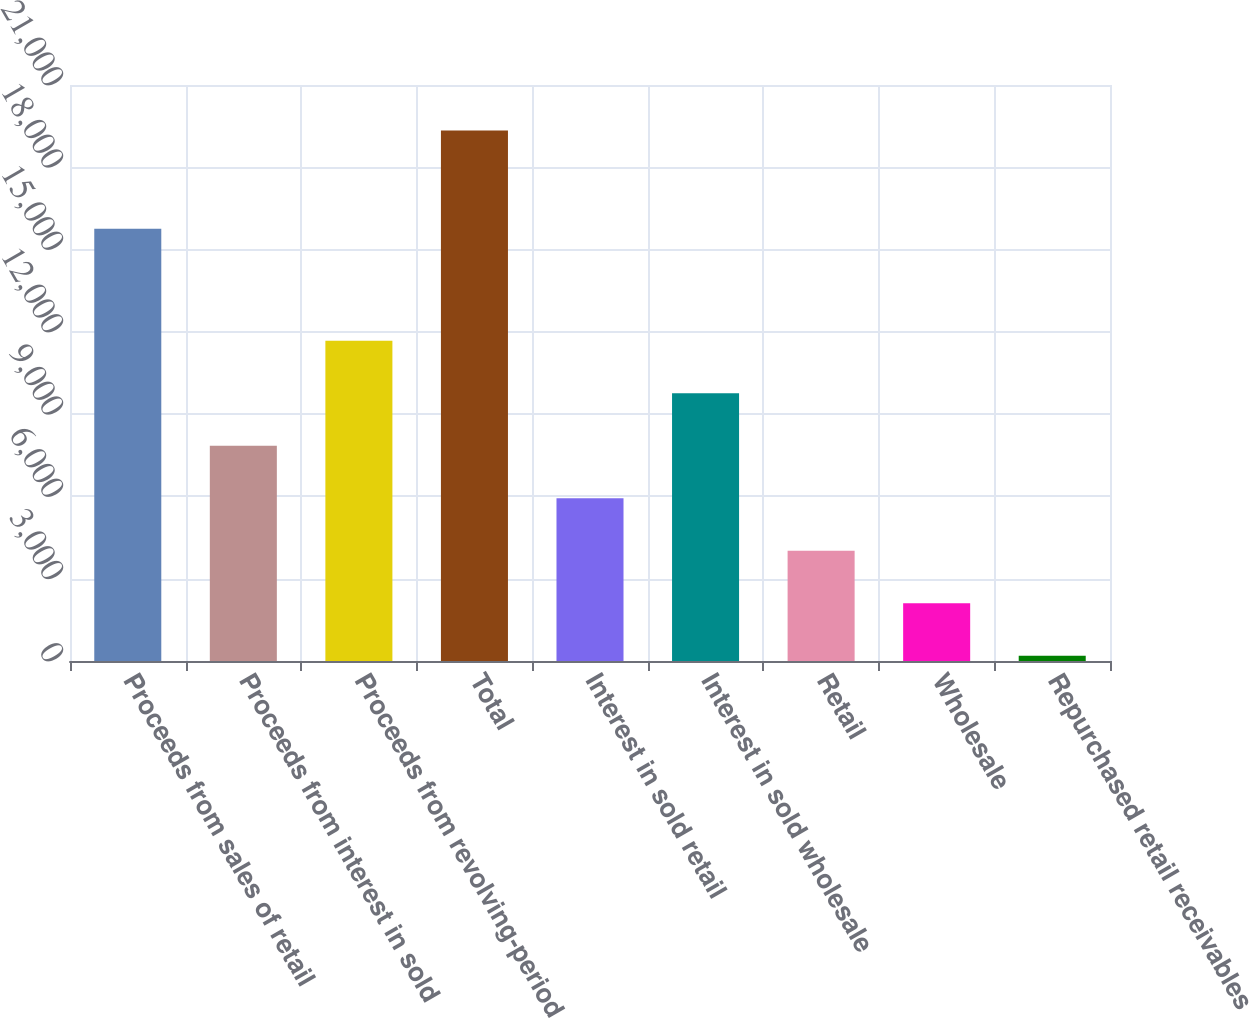Convert chart. <chart><loc_0><loc_0><loc_500><loc_500><bar_chart><fcel>Proceeds from sales of retail<fcel>Proceeds from interest in sold<fcel>Proceeds from revolving-period<fcel>Total<fcel>Interest in sold retail<fcel>Interest in sold wholesale<fcel>Retail<fcel>Wholesale<fcel>Repurchased retail receivables<nl><fcel>15761<fcel>7850.6<fcel>11679.4<fcel>19337<fcel>5936.2<fcel>9765<fcel>4021.8<fcel>2107.4<fcel>193<nl></chart> 